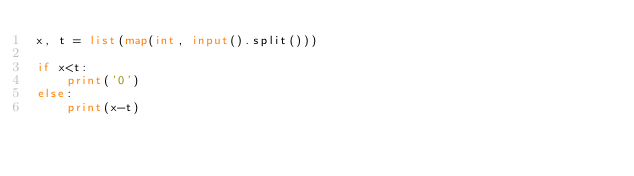<code> <loc_0><loc_0><loc_500><loc_500><_Python_>x, t = list(map(int, input().split()))

if x<t:
	print('0')
else:
	print(x-t)
	</code> 